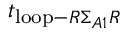Convert formula to latex. <formula><loc_0><loc_0><loc_500><loc_500>t _ { l o o p - R \Sigma _ { A 1 } R }</formula> 